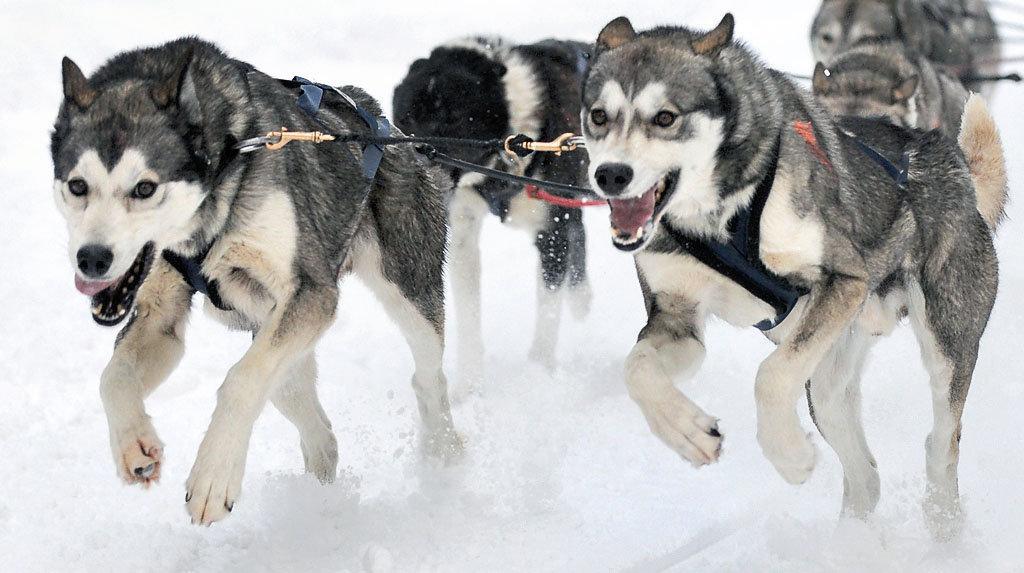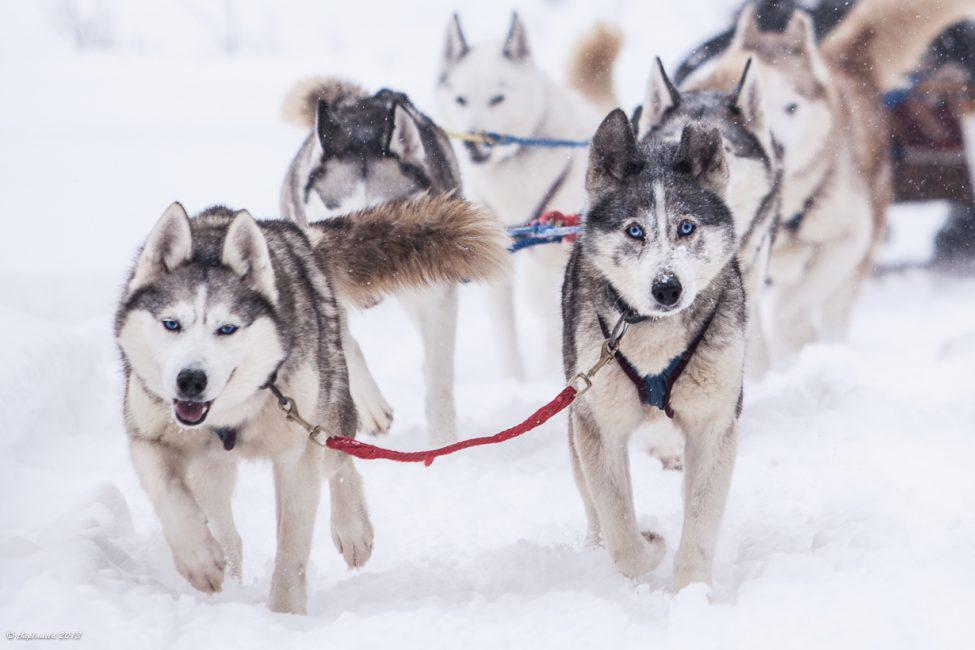The first image is the image on the left, the second image is the image on the right. Evaluate the accuracy of this statement regarding the images: "The right image features multiple husky dogs with dark-and-white fur and no booties racing toward the camera with tongues hanging out.". Is it true? Answer yes or no. No. The first image is the image on the left, the second image is the image on the right. Examine the images to the left and right. Is the description "Exactly one of the lead dogs has both front paws off the ground." accurate? Answer yes or no. No. 